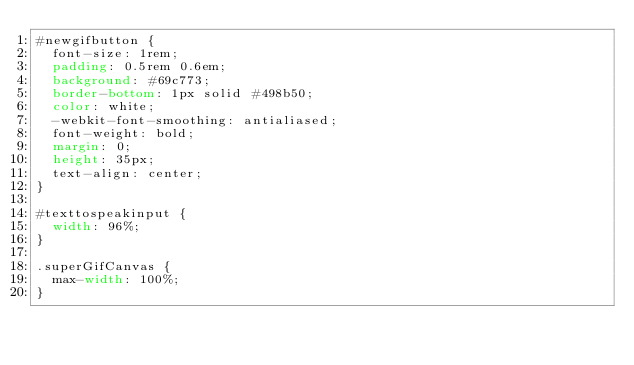Convert code to text. <code><loc_0><loc_0><loc_500><loc_500><_CSS_>#newgifbutton {
  font-size: 1rem;
  padding: 0.5rem 0.6em;
  background: #69c773;
  border-bottom: 1px solid #498b50;
  color: white;
  -webkit-font-smoothing: antialiased;
  font-weight: bold;
  margin: 0;
  height: 35px;
  text-align: center;
}

#texttospeakinput {
  width: 96%;
}

.superGifCanvas {
  max-width: 100%;
}
</code> 